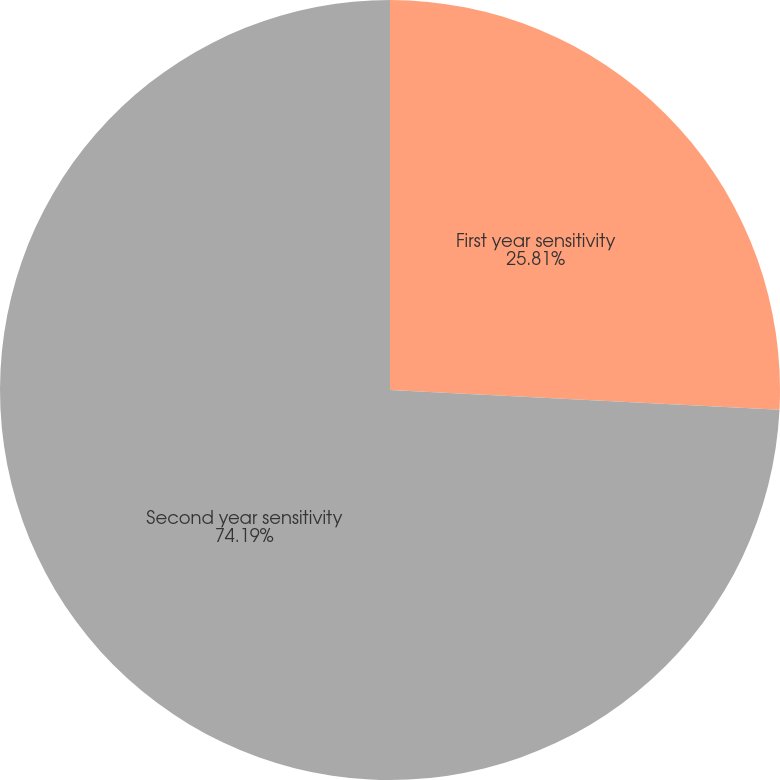<chart> <loc_0><loc_0><loc_500><loc_500><pie_chart><fcel>First year sensitivity<fcel>Second year sensitivity<nl><fcel>25.81%<fcel>74.19%<nl></chart> 